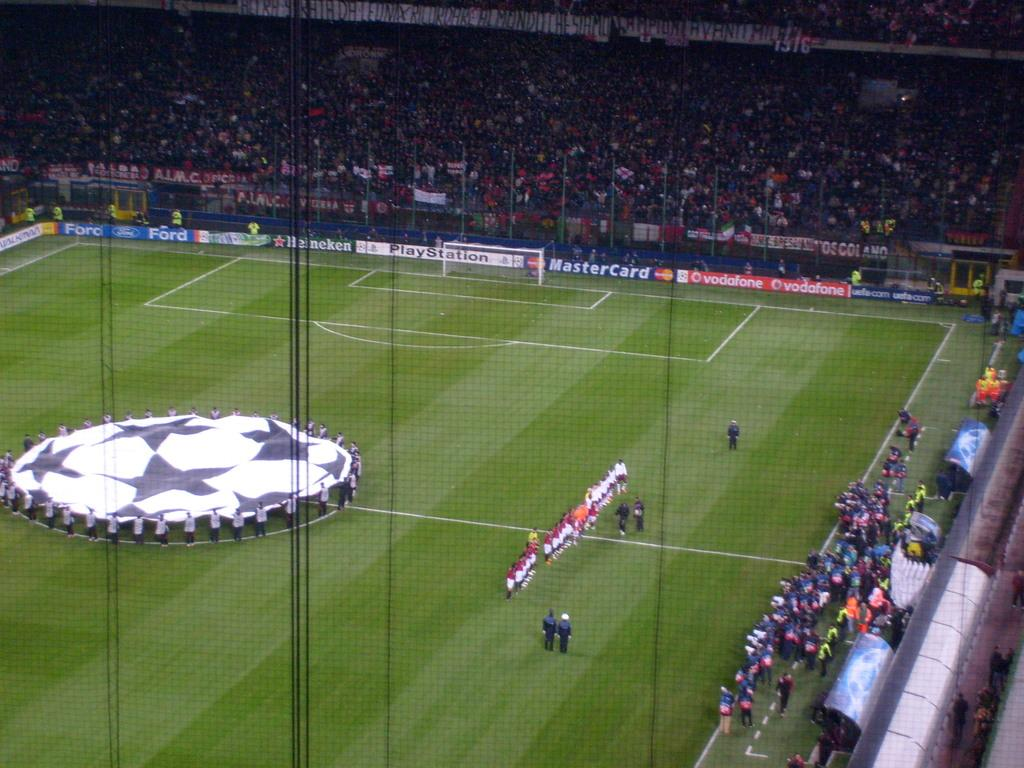<image>
Offer a succinct explanation of the picture presented. A Mastercard ad can be see  on the sign of a soccer field 